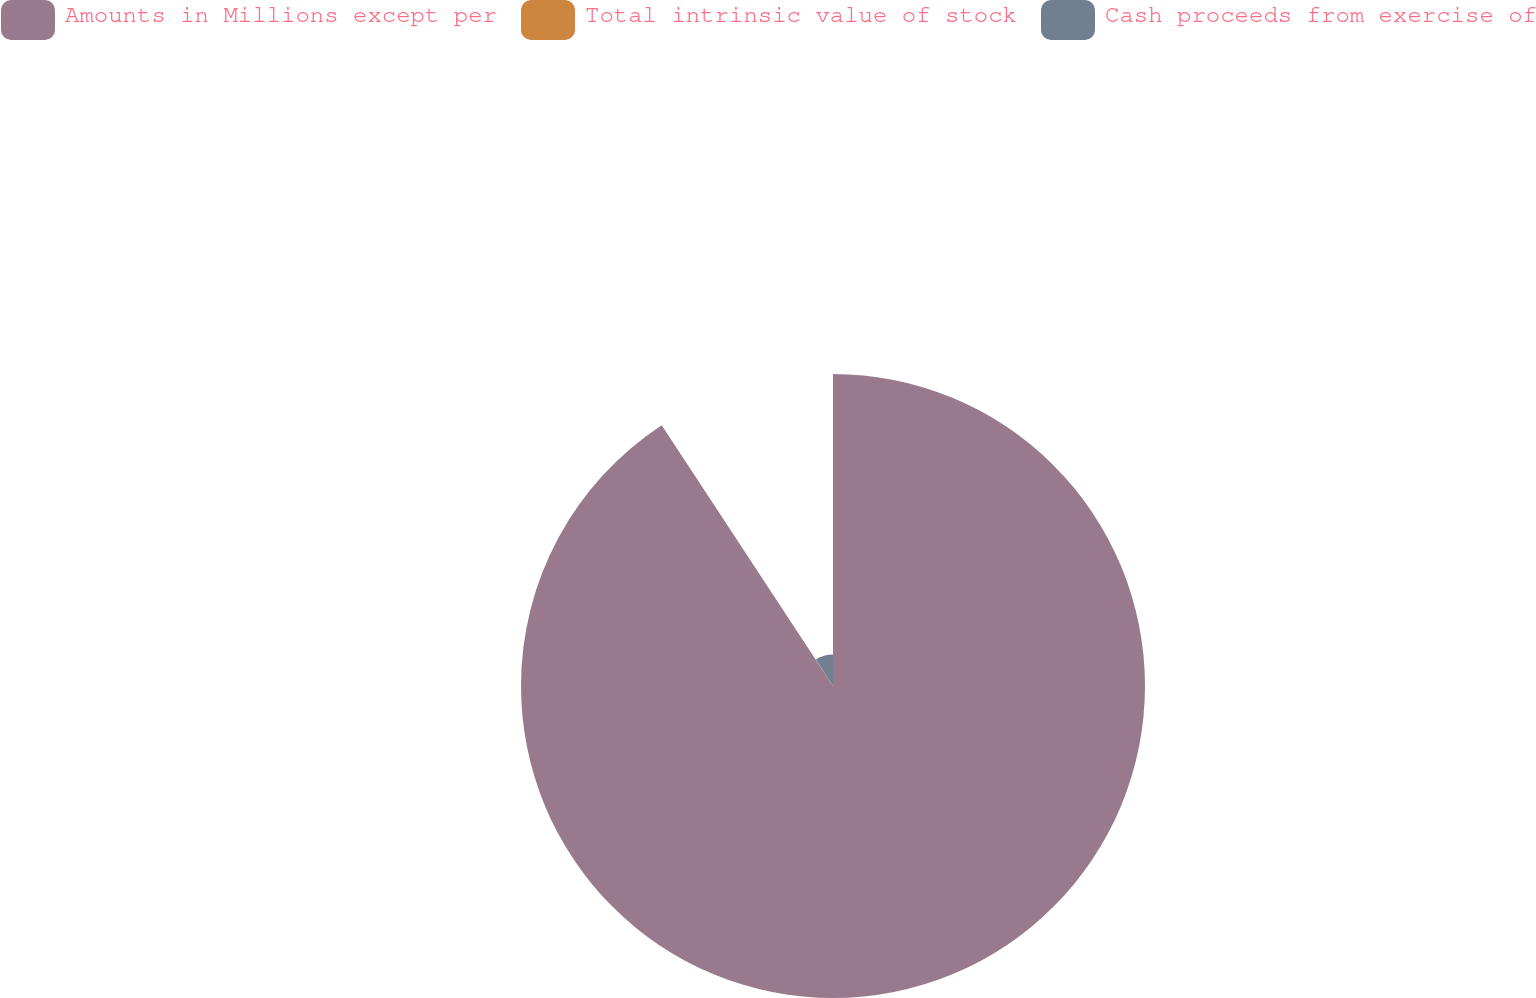Convert chart to OTSL. <chart><loc_0><loc_0><loc_500><loc_500><pie_chart><fcel>Amounts in Millions except per<fcel>Total intrinsic value of stock<fcel>Cash proceeds from exercise of<nl><fcel>90.75%<fcel>0.09%<fcel>9.16%<nl></chart> 